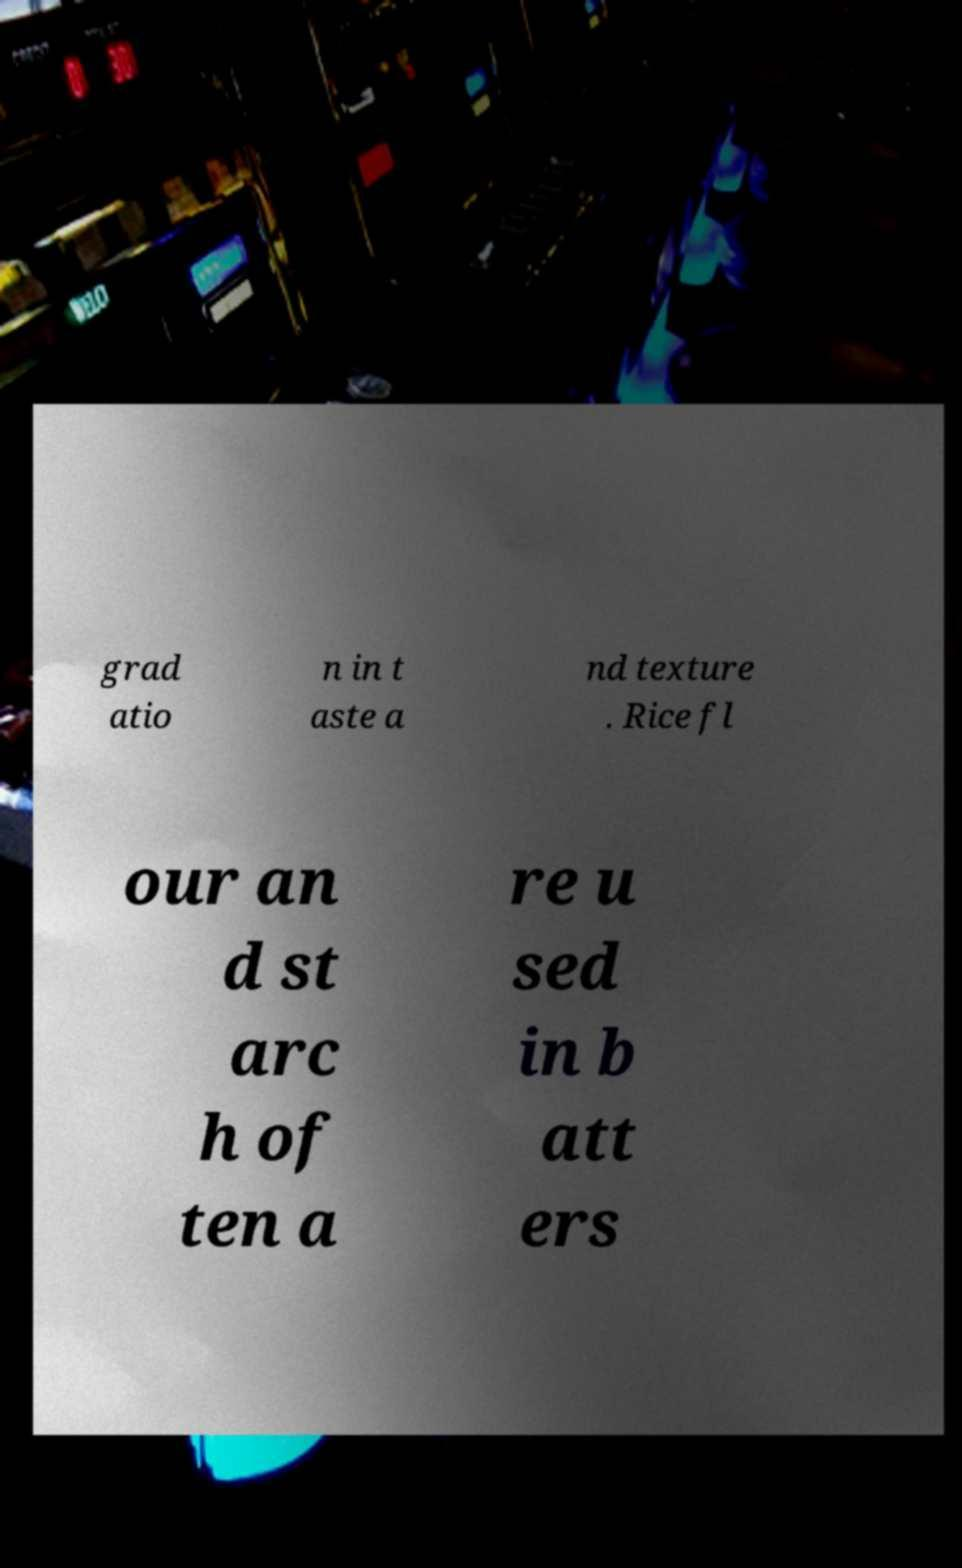I need the written content from this picture converted into text. Can you do that? grad atio n in t aste a nd texture . Rice fl our an d st arc h of ten a re u sed in b att ers 